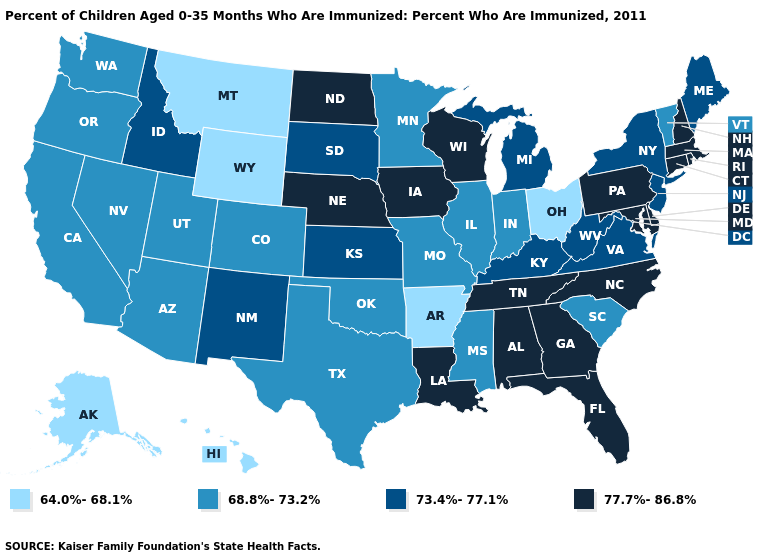Which states have the lowest value in the West?
Quick response, please. Alaska, Hawaii, Montana, Wyoming. Name the states that have a value in the range 68.8%-73.2%?
Keep it brief. Arizona, California, Colorado, Illinois, Indiana, Minnesota, Mississippi, Missouri, Nevada, Oklahoma, Oregon, South Carolina, Texas, Utah, Vermont, Washington. How many symbols are there in the legend?
Be succinct. 4. What is the value of New Hampshire?
Quick response, please. 77.7%-86.8%. Among the states that border Texas , which have the highest value?
Keep it brief. Louisiana. What is the value of Vermont?
Write a very short answer. 68.8%-73.2%. Does the first symbol in the legend represent the smallest category?
Give a very brief answer. Yes. Does Ohio have the lowest value in the MidWest?
Concise answer only. Yes. Name the states that have a value in the range 77.7%-86.8%?
Give a very brief answer. Alabama, Connecticut, Delaware, Florida, Georgia, Iowa, Louisiana, Maryland, Massachusetts, Nebraska, New Hampshire, North Carolina, North Dakota, Pennsylvania, Rhode Island, Tennessee, Wisconsin. Does Montana have the lowest value in the USA?
Concise answer only. Yes. Does the map have missing data?
Keep it brief. No. What is the value of Utah?
Concise answer only. 68.8%-73.2%. What is the value of Oklahoma?
Answer briefly. 68.8%-73.2%. Does Delaware have a higher value than West Virginia?
Be succinct. Yes. Among the states that border Oklahoma , which have the lowest value?
Quick response, please. Arkansas. 